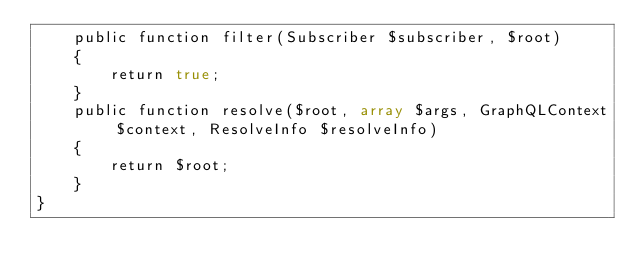Convert code to text. <code><loc_0><loc_0><loc_500><loc_500><_PHP_>    public function filter(Subscriber $subscriber, $root)
    {
        return true;
    }
    public function resolve($root, array $args, GraphQLContext $context, ResolveInfo $resolveInfo)
    {
        return $root;
    }
}</code> 